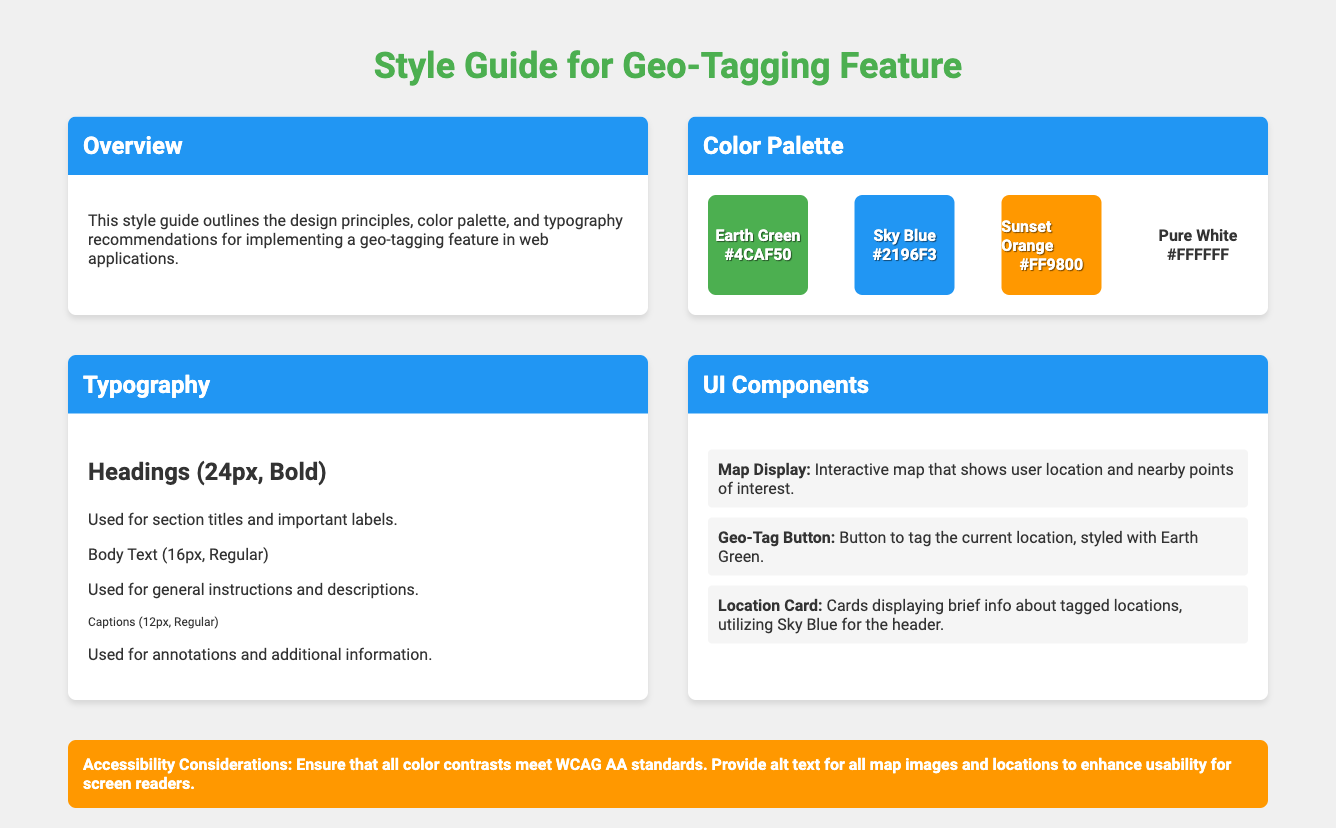What is the primary color of headings? The primary color for headings is specified in the style guide, which is used for section titles and important labels.
Answer: #4CAF50 How many typography examples are listed? The typography section includes examples for different text styles: Headings, Body Text, and Captions.
Answer: 3 What is the background color of the container? The background color for the container is defined in the CSS for the body.
Answer: #f0f0f0 What is the accent color for the Geo-Tag Button? The Geo-Tag Button uses a specific color that is highlighted in the UI Components section of the document.
Answer: Earth Green What is the font family recommended in this style guide? The font family is specified for use throughout the document and is consistent for all text styles.
Answer: Roboto What is the size for body text? The body text size is specifically indicated in the typography recommendations for regular text usage.
Answer: 16px How many color boxes are included in the color palette? The color palette consists of a number of distinct color representations corresponding to different thematic colors.
Answer: 4 What is emphasized under accessibility considerations? The accessibility section outlines important conditions to meet for usability regarding color contrast and alternate text.
Answer: WCAG AA standards What type of document is this? The document is focused on design principles, aimed at guiding developers in the implementation of a specific feature.
Answer: Style Guide 